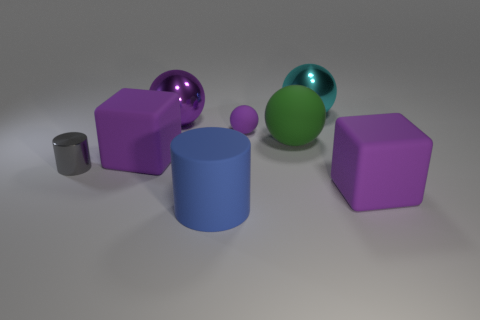Subtract 1 spheres. How many spheres are left? 3 Add 1 gray metallic things. How many objects exist? 9 Subtract all cubes. How many objects are left? 6 Add 5 purple rubber things. How many purple rubber things exist? 8 Subtract 1 purple balls. How many objects are left? 7 Subtract all big cyan objects. Subtract all small shiny cylinders. How many objects are left? 6 Add 1 tiny gray cylinders. How many tiny gray cylinders are left? 2 